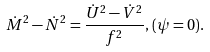<formula> <loc_0><loc_0><loc_500><loc_500>\dot { M } ^ { 2 } - \dot { N } ^ { 2 } = \frac { \dot { U } ^ { 2 } - \dot { V } ^ { 2 } } { f ^ { 2 } } , \, ( \psi = 0 ) .</formula> 